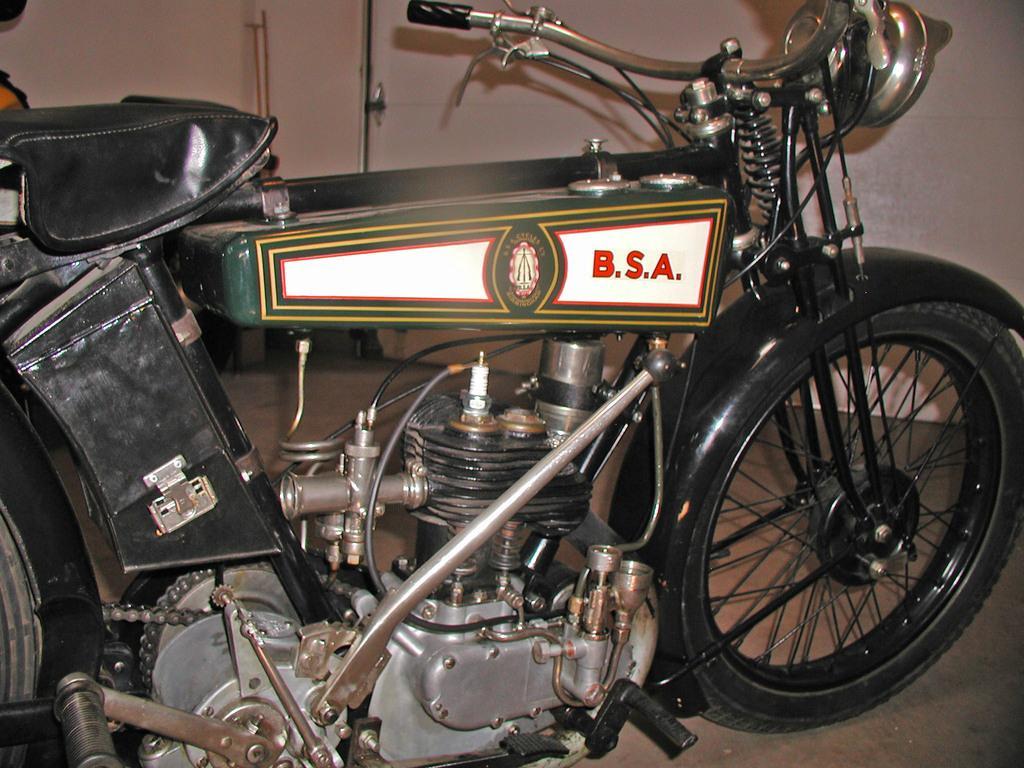Please provide a concise description of this image. In this picture I can observe a bike. There is some text on the white background. In the background there is a wall. 